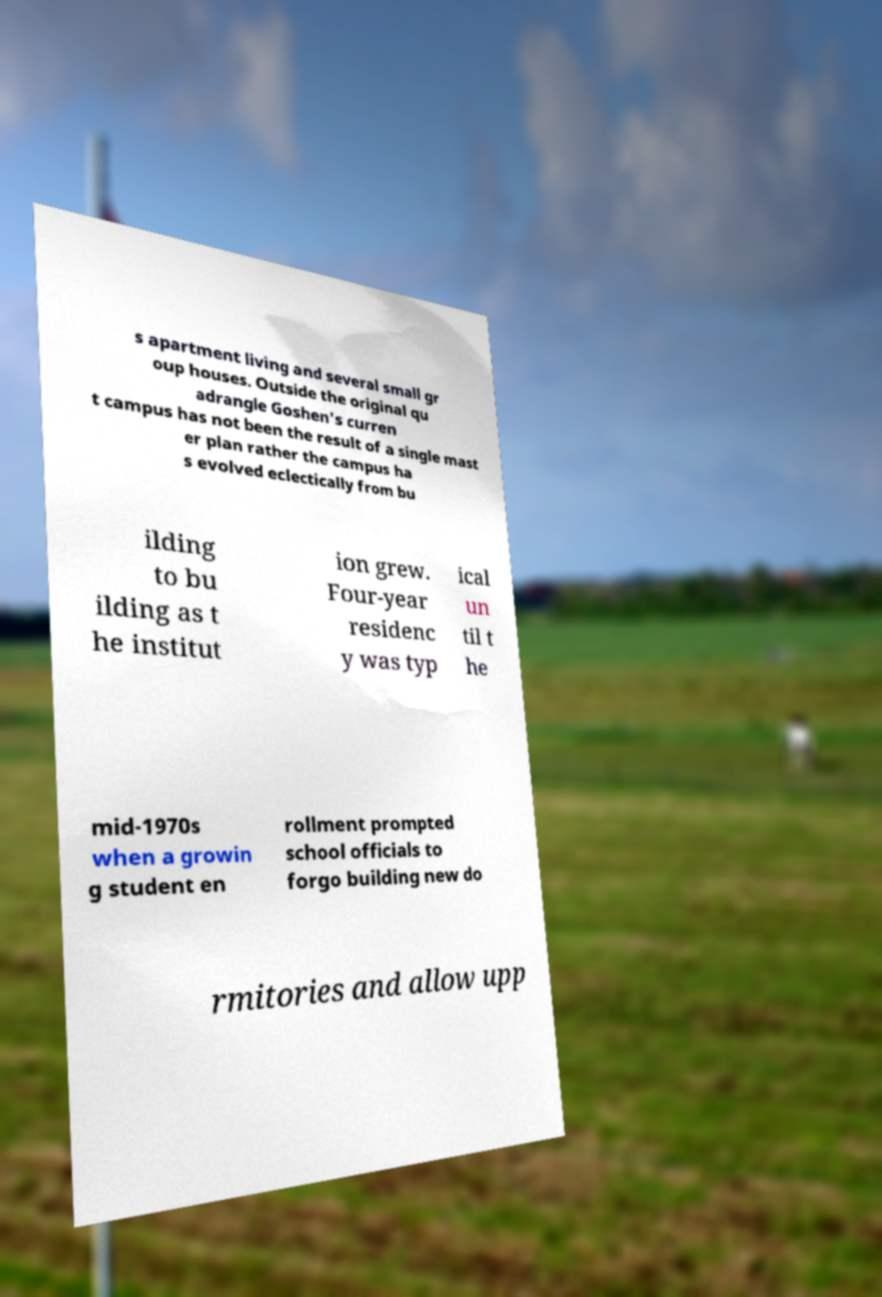For documentation purposes, I need the text within this image transcribed. Could you provide that? s apartment living and several small gr oup houses. Outside the original qu adrangle Goshen's curren t campus has not been the result of a single mast er plan rather the campus ha s evolved eclectically from bu ilding to bu ilding as t he institut ion grew. Four-year residenc y was typ ical un til t he mid-1970s when a growin g student en rollment prompted school officials to forgo building new do rmitories and allow upp 